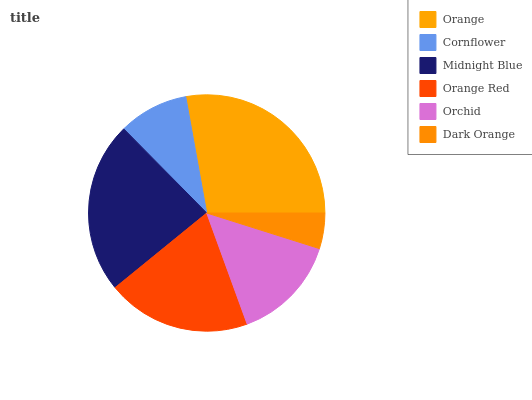Is Dark Orange the minimum?
Answer yes or no. Yes. Is Orange the maximum?
Answer yes or no. Yes. Is Cornflower the minimum?
Answer yes or no. No. Is Cornflower the maximum?
Answer yes or no. No. Is Orange greater than Cornflower?
Answer yes or no. Yes. Is Cornflower less than Orange?
Answer yes or no. Yes. Is Cornflower greater than Orange?
Answer yes or no. No. Is Orange less than Cornflower?
Answer yes or no. No. Is Orange Red the high median?
Answer yes or no. Yes. Is Orchid the low median?
Answer yes or no. Yes. Is Orange the high median?
Answer yes or no. No. Is Cornflower the low median?
Answer yes or no. No. 